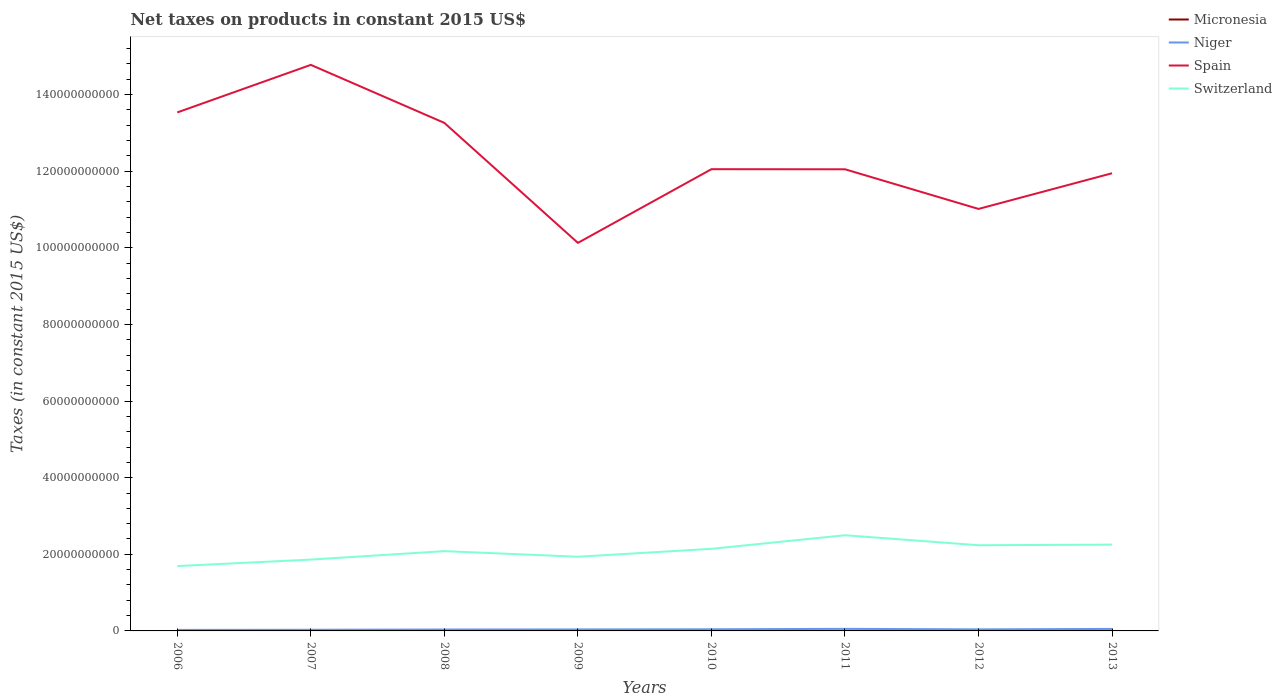How many different coloured lines are there?
Offer a very short reply. 4. Does the line corresponding to Micronesia intersect with the line corresponding to Switzerland?
Give a very brief answer. No. Is the number of lines equal to the number of legend labels?
Your answer should be very brief. Yes. Across all years, what is the maximum net taxes on products in Niger?
Offer a very short reply. 2.64e+08. What is the total net taxes on products in Niger in the graph?
Keep it short and to the point. -9.48e+07. What is the difference between the highest and the second highest net taxes on products in Switzerland?
Your answer should be very brief. 8.05e+09. What is the difference between the highest and the lowest net taxes on products in Niger?
Provide a short and direct response. 4. How many lines are there?
Ensure brevity in your answer.  4. How many years are there in the graph?
Your answer should be compact. 8. Does the graph contain grids?
Keep it short and to the point. No. Where does the legend appear in the graph?
Your answer should be compact. Top right. How many legend labels are there?
Keep it short and to the point. 4. What is the title of the graph?
Your answer should be very brief. Net taxes on products in constant 2015 US$. What is the label or title of the X-axis?
Your answer should be compact. Years. What is the label or title of the Y-axis?
Ensure brevity in your answer.  Taxes (in constant 2015 US$). What is the Taxes (in constant 2015 US$) of Micronesia in 2006?
Your answer should be very brief. 2.11e+07. What is the Taxes (in constant 2015 US$) of Niger in 2006?
Provide a short and direct response. 2.64e+08. What is the Taxes (in constant 2015 US$) in Spain in 2006?
Keep it short and to the point. 1.35e+11. What is the Taxes (in constant 2015 US$) of Switzerland in 2006?
Offer a terse response. 1.69e+1. What is the Taxes (in constant 2015 US$) in Micronesia in 2007?
Provide a succinct answer. 2.04e+07. What is the Taxes (in constant 2015 US$) in Niger in 2007?
Offer a very short reply. 3.02e+08. What is the Taxes (in constant 2015 US$) in Spain in 2007?
Your answer should be very brief. 1.48e+11. What is the Taxes (in constant 2015 US$) in Switzerland in 2007?
Ensure brevity in your answer.  1.86e+1. What is the Taxes (in constant 2015 US$) of Micronesia in 2008?
Ensure brevity in your answer.  1.88e+07. What is the Taxes (in constant 2015 US$) of Niger in 2008?
Provide a succinct answer. 3.72e+08. What is the Taxes (in constant 2015 US$) of Spain in 2008?
Offer a very short reply. 1.33e+11. What is the Taxes (in constant 2015 US$) of Switzerland in 2008?
Give a very brief answer. 2.08e+1. What is the Taxes (in constant 2015 US$) of Micronesia in 2009?
Give a very brief answer. 2.20e+07. What is the Taxes (in constant 2015 US$) in Niger in 2009?
Your response must be concise. 3.93e+08. What is the Taxes (in constant 2015 US$) of Spain in 2009?
Your response must be concise. 1.01e+11. What is the Taxes (in constant 2015 US$) in Switzerland in 2009?
Your answer should be very brief. 1.94e+1. What is the Taxes (in constant 2015 US$) in Micronesia in 2010?
Offer a very short reply. 2.54e+07. What is the Taxes (in constant 2015 US$) in Niger in 2010?
Keep it short and to the point. 4.28e+08. What is the Taxes (in constant 2015 US$) of Spain in 2010?
Provide a succinct answer. 1.21e+11. What is the Taxes (in constant 2015 US$) in Switzerland in 2010?
Ensure brevity in your answer.  2.14e+1. What is the Taxes (in constant 2015 US$) of Micronesia in 2011?
Your response must be concise. 2.60e+07. What is the Taxes (in constant 2015 US$) of Niger in 2011?
Your answer should be very brief. 5.44e+08. What is the Taxes (in constant 2015 US$) in Spain in 2011?
Offer a very short reply. 1.21e+11. What is the Taxes (in constant 2015 US$) in Switzerland in 2011?
Keep it short and to the point. 2.50e+1. What is the Taxes (in constant 2015 US$) of Micronesia in 2012?
Keep it short and to the point. 2.63e+07. What is the Taxes (in constant 2015 US$) in Niger in 2012?
Give a very brief answer. 4.09e+08. What is the Taxes (in constant 2015 US$) of Spain in 2012?
Give a very brief answer. 1.10e+11. What is the Taxes (in constant 2015 US$) of Switzerland in 2012?
Your response must be concise. 2.24e+1. What is the Taxes (in constant 2015 US$) in Micronesia in 2013?
Give a very brief answer. 2.59e+07. What is the Taxes (in constant 2015 US$) of Niger in 2013?
Your response must be concise. 5.23e+08. What is the Taxes (in constant 2015 US$) of Spain in 2013?
Make the answer very short. 1.19e+11. What is the Taxes (in constant 2015 US$) of Switzerland in 2013?
Give a very brief answer. 2.25e+1. Across all years, what is the maximum Taxes (in constant 2015 US$) of Micronesia?
Ensure brevity in your answer.  2.63e+07. Across all years, what is the maximum Taxes (in constant 2015 US$) in Niger?
Provide a short and direct response. 5.44e+08. Across all years, what is the maximum Taxes (in constant 2015 US$) in Spain?
Provide a succinct answer. 1.48e+11. Across all years, what is the maximum Taxes (in constant 2015 US$) in Switzerland?
Your answer should be compact. 2.50e+1. Across all years, what is the minimum Taxes (in constant 2015 US$) in Micronesia?
Offer a terse response. 1.88e+07. Across all years, what is the minimum Taxes (in constant 2015 US$) in Niger?
Offer a terse response. 2.64e+08. Across all years, what is the minimum Taxes (in constant 2015 US$) of Spain?
Your answer should be compact. 1.01e+11. Across all years, what is the minimum Taxes (in constant 2015 US$) in Switzerland?
Offer a terse response. 1.69e+1. What is the total Taxes (in constant 2015 US$) of Micronesia in the graph?
Make the answer very short. 1.86e+08. What is the total Taxes (in constant 2015 US$) in Niger in the graph?
Make the answer very short. 3.24e+09. What is the total Taxes (in constant 2015 US$) in Spain in the graph?
Offer a terse response. 9.88e+11. What is the total Taxes (in constant 2015 US$) of Switzerland in the graph?
Offer a terse response. 1.67e+11. What is the difference between the Taxes (in constant 2015 US$) in Micronesia in 2006 and that in 2007?
Ensure brevity in your answer.  6.88e+05. What is the difference between the Taxes (in constant 2015 US$) in Niger in 2006 and that in 2007?
Provide a short and direct response. -3.77e+07. What is the difference between the Taxes (in constant 2015 US$) in Spain in 2006 and that in 2007?
Provide a succinct answer. -1.24e+1. What is the difference between the Taxes (in constant 2015 US$) of Switzerland in 2006 and that in 2007?
Your response must be concise. -1.69e+09. What is the difference between the Taxes (in constant 2015 US$) in Micronesia in 2006 and that in 2008?
Offer a terse response. 2.27e+06. What is the difference between the Taxes (in constant 2015 US$) of Niger in 2006 and that in 2008?
Ensure brevity in your answer.  -1.07e+08. What is the difference between the Taxes (in constant 2015 US$) of Spain in 2006 and that in 2008?
Your response must be concise. 2.73e+09. What is the difference between the Taxes (in constant 2015 US$) in Switzerland in 2006 and that in 2008?
Offer a very short reply. -3.90e+09. What is the difference between the Taxes (in constant 2015 US$) of Micronesia in 2006 and that in 2009?
Give a very brief answer. -9.20e+05. What is the difference between the Taxes (in constant 2015 US$) in Niger in 2006 and that in 2009?
Provide a short and direct response. -1.29e+08. What is the difference between the Taxes (in constant 2015 US$) of Spain in 2006 and that in 2009?
Give a very brief answer. 3.40e+1. What is the difference between the Taxes (in constant 2015 US$) in Switzerland in 2006 and that in 2009?
Keep it short and to the point. -2.43e+09. What is the difference between the Taxes (in constant 2015 US$) in Micronesia in 2006 and that in 2010?
Offer a terse response. -4.33e+06. What is the difference between the Taxes (in constant 2015 US$) in Niger in 2006 and that in 2010?
Your answer should be compact. -1.64e+08. What is the difference between the Taxes (in constant 2015 US$) in Spain in 2006 and that in 2010?
Make the answer very short. 1.48e+1. What is the difference between the Taxes (in constant 2015 US$) in Switzerland in 2006 and that in 2010?
Your answer should be compact. -4.50e+09. What is the difference between the Taxes (in constant 2015 US$) in Micronesia in 2006 and that in 2011?
Give a very brief answer. -4.92e+06. What is the difference between the Taxes (in constant 2015 US$) in Niger in 2006 and that in 2011?
Provide a short and direct response. -2.79e+08. What is the difference between the Taxes (in constant 2015 US$) in Spain in 2006 and that in 2011?
Make the answer very short. 1.48e+1. What is the difference between the Taxes (in constant 2015 US$) in Switzerland in 2006 and that in 2011?
Offer a very short reply. -8.05e+09. What is the difference between the Taxes (in constant 2015 US$) in Micronesia in 2006 and that in 2012?
Ensure brevity in your answer.  -5.20e+06. What is the difference between the Taxes (in constant 2015 US$) in Niger in 2006 and that in 2012?
Your answer should be compact. -1.45e+08. What is the difference between the Taxes (in constant 2015 US$) in Spain in 2006 and that in 2012?
Provide a succinct answer. 2.52e+1. What is the difference between the Taxes (in constant 2015 US$) in Switzerland in 2006 and that in 2012?
Make the answer very short. -5.44e+09. What is the difference between the Taxes (in constant 2015 US$) in Micronesia in 2006 and that in 2013?
Your answer should be very brief. -4.80e+06. What is the difference between the Taxes (in constant 2015 US$) of Niger in 2006 and that in 2013?
Make the answer very short. -2.59e+08. What is the difference between the Taxes (in constant 2015 US$) in Spain in 2006 and that in 2013?
Offer a terse response. 1.59e+1. What is the difference between the Taxes (in constant 2015 US$) of Switzerland in 2006 and that in 2013?
Your answer should be compact. -5.60e+09. What is the difference between the Taxes (in constant 2015 US$) in Micronesia in 2007 and that in 2008?
Provide a short and direct response. 1.59e+06. What is the difference between the Taxes (in constant 2015 US$) of Niger in 2007 and that in 2008?
Keep it short and to the point. -6.97e+07. What is the difference between the Taxes (in constant 2015 US$) of Spain in 2007 and that in 2008?
Your answer should be very brief. 1.51e+1. What is the difference between the Taxes (in constant 2015 US$) in Switzerland in 2007 and that in 2008?
Offer a very short reply. -2.21e+09. What is the difference between the Taxes (in constant 2015 US$) in Micronesia in 2007 and that in 2009?
Your answer should be compact. -1.61e+06. What is the difference between the Taxes (in constant 2015 US$) of Niger in 2007 and that in 2009?
Your response must be concise. -9.09e+07. What is the difference between the Taxes (in constant 2015 US$) of Spain in 2007 and that in 2009?
Keep it short and to the point. 4.65e+1. What is the difference between the Taxes (in constant 2015 US$) of Switzerland in 2007 and that in 2009?
Your response must be concise. -7.42e+08. What is the difference between the Taxes (in constant 2015 US$) in Micronesia in 2007 and that in 2010?
Your answer should be very brief. -5.02e+06. What is the difference between the Taxes (in constant 2015 US$) of Niger in 2007 and that in 2010?
Give a very brief answer. -1.26e+08. What is the difference between the Taxes (in constant 2015 US$) in Spain in 2007 and that in 2010?
Your response must be concise. 2.72e+1. What is the difference between the Taxes (in constant 2015 US$) of Switzerland in 2007 and that in 2010?
Provide a succinct answer. -2.81e+09. What is the difference between the Taxes (in constant 2015 US$) in Micronesia in 2007 and that in 2011?
Provide a short and direct response. -5.61e+06. What is the difference between the Taxes (in constant 2015 US$) of Niger in 2007 and that in 2011?
Ensure brevity in your answer.  -2.42e+08. What is the difference between the Taxes (in constant 2015 US$) of Spain in 2007 and that in 2011?
Your answer should be compact. 2.73e+1. What is the difference between the Taxes (in constant 2015 US$) in Switzerland in 2007 and that in 2011?
Provide a short and direct response. -6.36e+09. What is the difference between the Taxes (in constant 2015 US$) in Micronesia in 2007 and that in 2012?
Your answer should be compact. -5.89e+06. What is the difference between the Taxes (in constant 2015 US$) of Niger in 2007 and that in 2012?
Give a very brief answer. -1.07e+08. What is the difference between the Taxes (in constant 2015 US$) of Spain in 2007 and that in 2012?
Offer a terse response. 3.76e+1. What is the difference between the Taxes (in constant 2015 US$) of Switzerland in 2007 and that in 2012?
Provide a succinct answer. -3.75e+09. What is the difference between the Taxes (in constant 2015 US$) of Micronesia in 2007 and that in 2013?
Your response must be concise. -5.49e+06. What is the difference between the Taxes (in constant 2015 US$) of Niger in 2007 and that in 2013?
Make the answer very short. -2.21e+08. What is the difference between the Taxes (in constant 2015 US$) of Spain in 2007 and that in 2013?
Your answer should be compact. 2.83e+1. What is the difference between the Taxes (in constant 2015 US$) of Switzerland in 2007 and that in 2013?
Make the answer very short. -3.91e+09. What is the difference between the Taxes (in constant 2015 US$) in Micronesia in 2008 and that in 2009?
Offer a very short reply. -3.19e+06. What is the difference between the Taxes (in constant 2015 US$) in Niger in 2008 and that in 2009?
Your answer should be compact. -2.12e+07. What is the difference between the Taxes (in constant 2015 US$) in Spain in 2008 and that in 2009?
Provide a succinct answer. 3.13e+1. What is the difference between the Taxes (in constant 2015 US$) in Switzerland in 2008 and that in 2009?
Give a very brief answer. 1.47e+09. What is the difference between the Taxes (in constant 2015 US$) of Micronesia in 2008 and that in 2010?
Make the answer very short. -6.60e+06. What is the difference between the Taxes (in constant 2015 US$) of Niger in 2008 and that in 2010?
Ensure brevity in your answer.  -5.65e+07. What is the difference between the Taxes (in constant 2015 US$) in Spain in 2008 and that in 2010?
Your answer should be very brief. 1.21e+1. What is the difference between the Taxes (in constant 2015 US$) of Switzerland in 2008 and that in 2010?
Give a very brief answer. -6.00e+08. What is the difference between the Taxes (in constant 2015 US$) in Micronesia in 2008 and that in 2011?
Keep it short and to the point. -7.19e+06. What is the difference between the Taxes (in constant 2015 US$) of Niger in 2008 and that in 2011?
Keep it short and to the point. -1.72e+08. What is the difference between the Taxes (in constant 2015 US$) of Spain in 2008 and that in 2011?
Offer a very short reply. 1.21e+1. What is the difference between the Taxes (in constant 2015 US$) of Switzerland in 2008 and that in 2011?
Your answer should be compact. -4.15e+09. What is the difference between the Taxes (in constant 2015 US$) of Micronesia in 2008 and that in 2012?
Provide a short and direct response. -7.48e+06. What is the difference between the Taxes (in constant 2015 US$) of Niger in 2008 and that in 2012?
Your answer should be very brief. -3.75e+07. What is the difference between the Taxes (in constant 2015 US$) of Spain in 2008 and that in 2012?
Your answer should be compact. 2.25e+1. What is the difference between the Taxes (in constant 2015 US$) in Switzerland in 2008 and that in 2012?
Offer a terse response. -1.54e+09. What is the difference between the Taxes (in constant 2015 US$) in Micronesia in 2008 and that in 2013?
Offer a terse response. -7.08e+06. What is the difference between the Taxes (in constant 2015 US$) of Niger in 2008 and that in 2013?
Give a very brief answer. -1.51e+08. What is the difference between the Taxes (in constant 2015 US$) of Spain in 2008 and that in 2013?
Give a very brief answer. 1.31e+1. What is the difference between the Taxes (in constant 2015 US$) of Switzerland in 2008 and that in 2013?
Your answer should be very brief. -1.70e+09. What is the difference between the Taxes (in constant 2015 US$) in Micronesia in 2009 and that in 2010?
Make the answer very short. -3.41e+06. What is the difference between the Taxes (in constant 2015 US$) in Niger in 2009 and that in 2010?
Make the answer very short. -3.53e+07. What is the difference between the Taxes (in constant 2015 US$) of Spain in 2009 and that in 2010?
Provide a succinct answer. -1.92e+1. What is the difference between the Taxes (in constant 2015 US$) of Switzerland in 2009 and that in 2010?
Make the answer very short. -2.07e+09. What is the difference between the Taxes (in constant 2015 US$) in Micronesia in 2009 and that in 2011?
Offer a very short reply. -4.00e+06. What is the difference between the Taxes (in constant 2015 US$) in Niger in 2009 and that in 2011?
Provide a succinct answer. -1.51e+08. What is the difference between the Taxes (in constant 2015 US$) in Spain in 2009 and that in 2011?
Offer a very short reply. -1.92e+1. What is the difference between the Taxes (in constant 2015 US$) in Switzerland in 2009 and that in 2011?
Keep it short and to the point. -5.62e+09. What is the difference between the Taxes (in constant 2015 US$) of Micronesia in 2009 and that in 2012?
Offer a terse response. -4.28e+06. What is the difference between the Taxes (in constant 2015 US$) in Niger in 2009 and that in 2012?
Offer a terse response. -1.63e+07. What is the difference between the Taxes (in constant 2015 US$) of Spain in 2009 and that in 2012?
Ensure brevity in your answer.  -8.86e+09. What is the difference between the Taxes (in constant 2015 US$) in Switzerland in 2009 and that in 2012?
Ensure brevity in your answer.  -3.01e+09. What is the difference between the Taxes (in constant 2015 US$) in Micronesia in 2009 and that in 2013?
Your answer should be compact. -3.88e+06. What is the difference between the Taxes (in constant 2015 US$) in Niger in 2009 and that in 2013?
Ensure brevity in your answer.  -1.30e+08. What is the difference between the Taxes (in constant 2015 US$) of Spain in 2009 and that in 2013?
Your answer should be compact. -1.82e+1. What is the difference between the Taxes (in constant 2015 US$) of Switzerland in 2009 and that in 2013?
Ensure brevity in your answer.  -3.17e+09. What is the difference between the Taxes (in constant 2015 US$) of Micronesia in 2010 and that in 2011?
Keep it short and to the point. -5.89e+05. What is the difference between the Taxes (in constant 2015 US$) in Niger in 2010 and that in 2011?
Your answer should be very brief. -1.16e+08. What is the difference between the Taxes (in constant 2015 US$) in Spain in 2010 and that in 2011?
Provide a short and direct response. 2.38e+07. What is the difference between the Taxes (in constant 2015 US$) of Switzerland in 2010 and that in 2011?
Provide a short and direct response. -3.55e+09. What is the difference between the Taxes (in constant 2015 US$) in Micronesia in 2010 and that in 2012?
Your response must be concise. -8.73e+05. What is the difference between the Taxes (in constant 2015 US$) in Niger in 2010 and that in 2012?
Your answer should be very brief. 1.90e+07. What is the difference between the Taxes (in constant 2015 US$) of Spain in 2010 and that in 2012?
Your answer should be compact. 1.04e+1. What is the difference between the Taxes (in constant 2015 US$) of Switzerland in 2010 and that in 2012?
Offer a very short reply. -9.41e+08. What is the difference between the Taxes (in constant 2015 US$) in Micronesia in 2010 and that in 2013?
Your answer should be very brief. -4.73e+05. What is the difference between the Taxes (in constant 2015 US$) in Niger in 2010 and that in 2013?
Offer a very short reply. -9.48e+07. What is the difference between the Taxes (in constant 2015 US$) in Spain in 2010 and that in 2013?
Provide a short and direct response. 1.06e+09. What is the difference between the Taxes (in constant 2015 US$) of Switzerland in 2010 and that in 2013?
Provide a short and direct response. -1.10e+09. What is the difference between the Taxes (in constant 2015 US$) in Micronesia in 2011 and that in 2012?
Offer a terse response. -2.83e+05. What is the difference between the Taxes (in constant 2015 US$) in Niger in 2011 and that in 2012?
Your answer should be very brief. 1.35e+08. What is the difference between the Taxes (in constant 2015 US$) of Spain in 2011 and that in 2012?
Your response must be concise. 1.04e+1. What is the difference between the Taxes (in constant 2015 US$) in Switzerland in 2011 and that in 2012?
Give a very brief answer. 2.61e+09. What is the difference between the Taxes (in constant 2015 US$) of Micronesia in 2011 and that in 2013?
Provide a short and direct response. 1.17e+05. What is the difference between the Taxes (in constant 2015 US$) of Niger in 2011 and that in 2013?
Your answer should be compact. 2.08e+07. What is the difference between the Taxes (in constant 2015 US$) in Spain in 2011 and that in 2013?
Provide a short and direct response. 1.04e+09. What is the difference between the Taxes (in constant 2015 US$) of Switzerland in 2011 and that in 2013?
Offer a very short reply. 2.45e+09. What is the difference between the Taxes (in constant 2015 US$) of Micronesia in 2012 and that in 2013?
Offer a very short reply. 4.00e+05. What is the difference between the Taxes (in constant 2015 US$) in Niger in 2012 and that in 2013?
Provide a succinct answer. -1.14e+08. What is the difference between the Taxes (in constant 2015 US$) in Spain in 2012 and that in 2013?
Your response must be concise. -9.31e+09. What is the difference between the Taxes (in constant 2015 US$) in Switzerland in 2012 and that in 2013?
Provide a succinct answer. -1.56e+08. What is the difference between the Taxes (in constant 2015 US$) of Micronesia in 2006 and the Taxes (in constant 2015 US$) of Niger in 2007?
Provide a short and direct response. -2.81e+08. What is the difference between the Taxes (in constant 2015 US$) of Micronesia in 2006 and the Taxes (in constant 2015 US$) of Spain in 2007?
Your response must be concise. -1.48e+11. What is the difference between the Taxes (in constant 2015 US$) in Micronesia in 2006 and the Taxes (in constant 2015 US$) in Switzerland in 2007?
Your answer should be compact. -1.86e+1. What is the difference between the Taxes (in constant 2015 US$) in Niger in 2006 and the Taxes (in constant 2015 US$) in Spain in 2007?
Ensure brevity in your answer.  -1.47e+11. What is the difference between the Taxes (in constant 2015 US$) of Niger in 2006 and the Taxes (in constant 2015 US$) of Switzerland in 2007?
Ensure brevity in your answer.  -1.84e+1. What is the difference between the Taxes (in constant 2015 US$) in Spain in 2006 and the Taxes (in constant 2015 US$) in Switzerland in 2007?
Your answer should be compact. 1.17e+11. What is the difference between the Taxes (in constant 2015 US$) in Micronesia in 2006 and the Taxes (in constant 2015 US$) in Niger in 2008?
Make the answer very short. -3.51e+08. What is the difference between the Taxes (in constant 2015 US$) of Micronesia in 2006 and the Taxes (in constant 2015 US$) of Spain in 2008?
Your answer should be compact. -1.33e+11. What is the difference between the Taxes (in constant 2015 US$) of Micronesia in 2006 and the Taxes (in constant 2015 US$) of Switzerland in 2008?
Your answer should be very brief. -2.08e+1. What is the difference between the Taxes (in constant 2015 US$) in Niger in 2006 and the Taxes (in constant 2015 US$) in Spain in 2008?
Your response must be concise. -1.32e+11. What is the difference between the Taxes (in constant 2015 US$) in Niger in 2006 and the Taxes (in constant 2015 US$) in Switzerland in 2008?
Offer a terse response. -2.06e+1. What is the difference between the Taxes (in constant 2015 US$) of Spain in 2006 and the Taxes (in constant 2015 US$) of Switzerland in 2008?
Give a very brief answer. 1.15e+11. What is the difference between the Taxes (in constant 2015 US$) of Micronesia in 2006 and the Taxes (in constant 2015 US$) of Niger in 2009?
Give a very brief answer. -3.72e+08. What is the difference between the Taxes (in constant 2015 US$) of Micronesia in 2006 and the Taxes (in constant 2015 US$) of Spain in 2009?
Provide a short and direct response. -1.01e+11. What is the difference between the Taxes (in constant 2015 US$) of Micronesia in 2006 and the Taxes (in constant 2015 US$) of Switzerland in 2009?
Your answer should be compact. -1.93e+1. What is the difference between the Taxes (in constant 2015 US$) of Niger in 2006 and the Taxes (in constant 2015 US$) of Spain in 2009?
Offer a very short reply. -1.01e+11. What is the difference between the Taxes (in constant 2015 US$) in Niger in 2006 and the Taxes (in constant 2015 US$) in Switzerland in 2009?
Provide a succinct answer. -1.91e+1. What is the difference between the Taxes (in constant 2015 US$) of Spain in 2006 and the Taxes (in constant 2015 US$) of Switzerland in 2009?
Ensure brevity in your answer.  1.16e+11. What is the difference between the Taxes (in constant 2015 US$) in Micronesia in 2006 and the Taxes (in constant 2015 US$) in Niger in 2010?
Offer a terse response. -4.07e+08. What is the difference between the Taxes (in constant 2015 US$) of Micronesia in 2006 and the Taxes (in constant 2015 US$) of Spain in 2010?
Keep it short and to the point. -1.21e+11. What is the difference between the Taxes (in constant 2015 US$) in Micronesia in 2006 and the Taxes (in constant 2015 US$) in Switzerland in 2010?
Keep it short and to the point. -2.14e+1. What is the difference between the Taxes (in constant 2015 US$) in Niger in 2006 and the Taxes (in constant 2015 US$) in Spain in 2010?
Make the answer very short. -1.20e+11. What is the difference between the Taxes (in constant 2015 US$) of Niger in 2006 and the Taxes (in constant 2015 US$) of Switzerland in 2010?
Your response must be concise. -2.12e+1. What is the difference between the Taxes (in constant 2015 US$) in Spain in 2006 and the Taxes (in constant 2015 US$) in Switzerland in 2010?
Make the answer very short. 1.14e+11. What is the difference between the Taxes (in constant 2015 US$) in Micronesia in 2006 and the Taxes (in constant 2015 US$) in Niger in 2011?
Provide a short and direct response. -5.23e+08. What is the difference between the Taxes (in constant 2015 US$) of Micronesia in 2006 and the Taxes (in constant 2015 US$) of Spain in 2011?
Your answer should be very brief. -1.20e+11. What is the difference between the Taxes (in constant 2015 US$) in Micronesia in 2006 and the Taxes (in constant 2015 US$) in Switzerland in 2011?
Keep it short and to the point. -2.50e+1. What is the difference between the Taxes (in constant 2015 US$) of Niger in 2006 and the Taxes (in constant 2015 US$) of Spain in 2011?
Provide a succinct answer. -1.20e+11. What is the difference between the Taxes (in constant 2015 US$) in Niger in 2006 and the Taxes (in constant 2015 US$) in Switzerland in 2011?
Offer a very short reply. -2.47e+1. What is the difference between the Taxes (in constant 2015 US$) of Spain in 2006 and the Taxes (in constant 2015 US$) of Switzerland in 2011?
Make the answer very short. 1.10e+11. What is the difference between the Taxes (in constant 2015 US$) of Micronesia in 2006 and the Taxes (in constant 2015 US$) of Niger in 2012?
Offer a terse response. -3.88e+08. What is the difference between the Taxes (in constant 2015 US$) of Micronesia in 2006 and the Taxes (in constant 2015 US$) of Spain in 2012?
Offer a terse response. -1.10e+11. What is the difference between the Taxes (in constant 2015 US$) in Micronesia in 2006 and the Taxes (in constant 2015 US$) in Switzerland in 2012?
Ensure brevity in your answer.  -2.23e+1. What is the difference between the Taxes (in constant 2015 US$) in Niger in 2006 and the Taxes (in constant 2015 US$) in Spain in 2012?
Ensure brevity in your answer.  -1.10e+11. What is the difference between the Taxes (in constant 2015 US$) of Niger in 2006 and the Taxes (in constant 2015 US$) of Switzerland in 2012?
Offer a very short reply. -2.21e+1. What is the difference between the Taxes (in constant 2015 US$) of Spain in 2006 and the Taxes (in constant 2015 US$) of Switzerland in 2012?
Provide a succinct answer. 1.13e+11. What is the difference between the Taxes (in constant 2015 US$) of Micronesia in 2006 and the Taxes (in constant 2015 US$) of Niger in 2013?
Keep it short and to the point. -5.02e+08. What is the difference between the Taxes (in constant 2015 US$) in Micronesia in 2006 and the Taxes (in constant 2015 US$) in Spain in 2013?
Your answer should be very brief. -1.19e+11. What is the difference between the Taxes (in constant 2015 US$) in Micronesia in 2006 and the Taxes (in constant 2015 US$) in Switzerland in 2013?
Provide a succinct answer. -2.25e+1. What is the difference between the Taxes (in constant 2015 US$) of Niger in 2006 and the Taxes (in constant 2015 US$) of Spain in 2013?
Ensure brevity in your answer.  -1.19e+11. What is the difference between the Taxes (in constant 2015 US$) of Niger in 2006 and the Taxes (in constant 2015 US$) of Switzerland in 2013?
Your response must be concise. -2.23e+1. What is the difference between the Taxes (in constant 2015 US$) of Spain in 2006 and the Taxes (in constant 2015 US$) of Switzerland in 2013?
Offer a very short reply. 1.13e+11. What is the difference between the Taxes (in constant 2015 US$) in Micronesia in 2007 and the Taxes (in constant 2015 US$) in Niger in 2008?
Make the answer very short. -3.51e+08. What is the difference between the Taxes (in constant 2015 US$) of Micronesia in 2007 and the Taxes (in constant 2015 US$) of Spain in 2008?
Make the answer very short. -1.33e+11. What is the difference between the Taxes (in constant 2015 US$) of Micronesia in 2007 and the Taxes (in constant 2015 US$) of Switzerland in 2008?
Provide a succinct answer. -2.08e+1. What is the difference between the Taxes (in constant 2015 US$) of Niger in 2007 and the Taxes (in constant 2015 US$) of Spain in 2008?
Make the answer very short. -1.32e+11. What is the difference between the Taxes (in constant 2015 US$) of Niger in 2007 and the Taxes (in constant 2015 US$) of Switzerland in 2008?
Give a very brief answer. -2.05e+1. What is the difference between the Taxes (in constant 2015 US$) in Spain in 2007 and the Taxes (in constant 2015 US$) in Switzerland in 2008?
Make the answer very short. 1.27e+11. What is the difference between the Taxes (in constant 2015 US$) of Micronesia in 2007 and the Taxes (in constant 2015 US$) of Niger in 2009?
Your response must be concise. -3.73e+08. What is the difference between the Taxes (in constant 2015 US$) of Micronesia in 2007 and the Taxes (in constant 2015 US$) of Spain in 2009?
Offer a terse response. -1.01e+11. What is the difference between the Taxes (in constant 2015 US$) of Micronesia in 2007 and the Taxes (in constant 2015 US$) of Switzerland in 2009?
Provide a short and direct response. -1.93e+1. What is the difference between the Taxes (in constant 2015 US$) of Niger in 2007 and the Taxes (in constant 2015 US$) of Spain in 2009?
Offer a very short reply. -1.01e+11. What is the difference between the Taxes (in constant 2015 US$) in Niger in 2007 and the Taxes (in constant 2015 US$) in Switzerland in 2009?
Your response must be concise. -1.91e+1. What is the difference between the Taxes (in constant 2015 US$) of Spain in 2007 and the Taxes (in constant 2015 US$) of Switzerland in 2009?
Keep it short and to the point. 1.28e+11. What is the difference between the Taxes (in constant 2015 US$) in Micronesia in 2007 and the Taxes (in constant 2015 US$) in Niger in 2010?
Your answer should be very brief. -4.08e+08. What is the difference between the Taxes (in constant 2015 US$) of Micronesia in 2007 and the Taxes (in constant 2015 US$) of Spain in 2010?
Give a very brief answer. -1.21e+11. What is the difference between the Taxes (in constant 2015 US$) of Micronesia in 2007 and the Taxes (in constant 2015 US$) of Switzerland in 2010?
Ensure brevity in your answer.  -2.14e+1. What is the difference between the Taxes (in constant 2015 US$) of Niger in 2007 and the Taxes (in constant 2015 US$) of Spain in 2010?
Keep it short and to the point. -1.20e+11. What is the difference between the Taxes (in constant 2015 US$) in Niger in 2007 and the Taxes (in constant 2015 US$) in Switzerland in 2010?
Your answer should be compact. -2.11e+1. What is the difference between the Taxes (in constant 2015 US$) of Spain in 2007 and the Taxes (in constant 2015 US$) of Switzerland in 2010?
Your response must be concise. 1.26e+11. What is the difference between the Taxes (in constant 2015 US$) in Micronesia in 2007 and the Taxes (in constant 2015 US$) in Niger in 2011?
Ensure brevity in your answer.  -5.23e+08. What is the difference between the Taxes (in constant 2015 US$) in Micronesia in 2007 and the Taxes (in constant 2015 US$) in Spain in 2011?
Ensure brevity in your answer.  -1.20e+11. What is the difference between the Taxes (in constant 2015 US$) in Micronesia in 2007 and the Taxes (in constant 2015 US$) in Switzerland in 2011?
Offer a very short reply. -2.50e+1. What is the difference between the Taxes (in constant 2015 US$) in Niger in 2007 and the Taxes (in constant 2015 US$) in Spain in 2011?
Make the answer very short. -1.20e+11. What is the difference between the Taxes (in constant 2015 US$) in Niger in 2007 and the Taxes (in constant 2015 US$) in Switzerland in 2011?
Provide a succinct answer. -2.47e+1. What is the difference between the Taxes (in constant 2015 US$) of Spain in 2007 and the Taxes (in constant 2015 US$) of Switzerland in 2011?
Ensure brevity in your answer.  1.23e+11. What is the difference between the Taxes (in constant 2015 US$) in Micronesia in 2007 and the Taxes (in constant 2015 US$) in Niger in 2012?
Your response must be concise. -3.89e+08. What is the difference between the Taxes (in constant 2015 US$) of Micronesia in 2007 and the Taxes (in constant 2015 US$) of Spain in 2012?
Ensure brevity in your answer.  -1.10e+11. What is the difference between the Taxes (in constant 2015 US$) of Micronesia in 2007 and the Taxes (in constant 2015 US$) of Switzerland in 2012?
Your response must be concise. -2.24e+1. What is the difference between the Taxes (in constant 2015 US$) of Niger in 2007 and the Taxes (in constant 2015 US$) of Spain in 2012?
Provide a succinct answer. -1.10e+11. What is the difference between the Taxes (in constant 2015 US$) in Niger in 2007 and the Taxes (in constant 2015 US$) in Switzerland in 2012?
Offer a terse response. -2.21e+1. What is the difference between the Taxes (in constant 2015 US$) of Spain in 2007 and the Taxes (in constant 2015 US$) of Switzerland in 2012?
Offer a very short reply. 1.25e+11. What is the difference between the Taxes (in constant 2015 US$) in Micronesia in 2007 and the Taxes (in constant 2015 US$) in Niger in 2013?
Offer a very short reply. -5.03e+08. What is the difference between the Taxes (in constant 2015 US$) in Micronesia in 2007 and the Taxes (in constant 2015 US$) in Spain in 2013?
Keep it short and to the point. -1.19e+11. What is the difference between the Taxes (in constant 2015 US$) of Micronesia in 2007 and the Taxes (in constant 2015 US$) of Switzerland in 2013?
Your answer should be compact. -2.25e+1. What is the difference between the Taxes (in constant 2015 US$) in Niger in 2007 and the Taxes (in constant 2015 US$) in Spain in 2013?
Offer a terse response. -1.19e+11. What is the difference between the Taxes (in constant 2015 US$) in Niger in 2007 and the Taxes (in constant 2015 US$) in Switzerland in 2013?
Provide a short and direct response. -2.22e+1. What is the difference between the Taxes (in constant 2015 US$) of Spain in 2007 and the Taxes (in constant 2015 US$) of Switzerland in 2013?
Your answer should be very brief. 1.25e+11. What is the difference between the Taxes (in constant 2015 US$) of Micronesia in 2008 and the Taxes (in constant 2015 US$) of Niger in 2009?
Offer a very short reply. -3.74e+08. What is the difference between the Taxes (in constant 2015 US$) in Micronesia in 2008 and the Taxes (in constant 2015 US$) in Spain in 2009?
Ensure brevity in your answer.  -1.01e+11. What is the difference between the Taxes (in constant 2015 US$) in Micronesia in 2008 and the Taxes (in constant 2015 US$) in Switzerland in 2009?
Offer a very short reply. -1.93e+1. What is the difference between the Taxes (in constant 2015 US$) in Niger in 2008 and the Taxes (in constant 2015 US$) in Spain in 2009?
Keep it short and to the point. -1.01e+11. What is the difference between the Taxes (in constant 2015 US$) in Niger in 2008 and the Taxes (in constant 2015 US$) in Switzerland in 2009?
Offer a very short reply. -1.90e+1. What is the difference between the Taxes (in constant 2015 US$) of Spain in 2008 and the Taxes (in constant 2015 US$) of Switzerland in 2009?
Offer a terse response. 1.13e+11. What is the difference between the Taxes (in constant 2015 US$) of Micronesia in 2008 and the Taxes (in constant 2015 US$) of Niger in 2010?
Provide a short and direct response. -4.09e+08. What is the difference between the Taxes (in constant 2015 US$) of Micronesia in 2008 and the Taxes (in constant 2015 US$) of Spain in 2010?
Ensure brevity in your answer.  -1.21e+11. What is the difference between the Taxes (in constant 2015 US$) in Micronesia in 2008 and the Taxes (in constant 2015 US$) in Switzerland in 2010?
Ensure brevity in your answer.  -2.14e+1. What is the difference between the Taxes (in constant 2015 US$) of Niger in 2008 and the Taxes (in constant 2015 US$) of Spain in 2010?
Give a very brief answer. -1.20e+11. What is the difference between the Taxes (in constant 2015 US$) of Niger in 2008 and the Taxes (in constant 2015 US$) of Switzerland in 2010?
Ensure brevity in your answer.  -2.11e+1. What is the difference between the Taxes (in constant 2015 US$) in Spain in 2008 and the Taxes (in constant 2015 US$) in Switzerland in 2010?
Offer a terse response. 1.11e+11. What is the difference between the Taxes (in constant 2015 US$) of Micronesia in 2008 and the Taxes (in constant 2015 US$) of Niger in 2011?
Give a very brief answer. -5.25e+08. What is the difference between the Taxes (in constant 2015 US$) of Micronesia in 2008 and the Taxes (in constant 2015 US$) of Spain in 2011?
Make the answer very short. -1.20e+11. What is the difference between the Taxes (in constant 2015 US$) in Micronesia in 2008 and the Taxes (in constant 2015 US$) in Switzerland in 2011?
Provide a succinct answer. -2.50e+1. What is the difference between the Taxes (in constant 2015 US$) in Niger in 2008 and the Taxes (in constant 2015 US$) in Spain in 2011?
Give a very brief answer. -1.20e+11. What is the difference between the Taxes (in constant 2015 US$) in Niger in 2008 and the Taxes (in constant 2015 US$) in Switzerland in 2011?
Provide a short and direct response. -2.46e+1. What is the difference between the Taxes (in constant 2015 US$) of Spain in 2008 and the Taxes (in constant 2015 US$) of Switzerland in 2011?
Offer a very short reply. 1.08e+11. What is the difference between the Taxes (in constant 2015 US$) of Micronesia in 2008 and the Taxes (in constant 2015 US$) of Niger in 2012?
Provide a short and direct response. -3.90e+08. What is the difference between the Taxes (in constant 2015 US$) of Micronesia in 2008 and the Taxes (in constant 2015 US$) of Spain in 2012?
Offer a very short reply. -1.10e+11. What is the difference between the Taxes (in constant 2015 US$) of Micronesia in 2008 and the Taxes (in constant 2015 US$) of Switzerland in 2012?
Provide a succinct answer. -2.24e+1. What is the difference between the Taxes (in constant 2015 US$) in Niger in 2008 and the Taxes (in constant 2015 US$) in Spain in 2012?
Make the answer very short. -1.10e+11. What is the difference between the Taxes (in constant 2015 US$) in Niger in 2008 and the Taxes (in constant 2015 US$) in Switzerland in 2012?
Keep it short and to the point. -2.20e+1. What is the difference between the Taxes (in constant 2015 US$) of Spain in 2008 and the Taxes (in constant 2015 US$) of Switzerland in 2012?
Provide a succinct answer. 1.10e+11. What is the difference between the Taxes (in constant 2015 US$) of Micronesia in 2008 and the Taxes (in constant 2015 US$) of Niger in 2013?
Offer a very short reply. -5.04e+08. What is the difference between the Taxes (in constant 2015 US$) of Micronesia in 2008 and the Taxes (in constant 2015 US$) of Spain in 2013?
Offer a terse response. -1.19e+11. What is the difference between the Taxes (in constant 2015 US$) in Micronesia in 2008 and the Taxes (in constant 2015 US$) in Switzerland in 2013?
Your response must be concise. -2.25e+1. What is the difference between the Taxes (in constant 2015 US$) in Niger in 2008 and the Taxes (in constant 2015 US$) in Spain in 2013?
Keep it short and to the point. -1.19e+11. What is the difference between the Taxes (in constant 2015 US$) in Niger in 2008 and the Taxes (in constant 2015 US$) in Switzerland in 2013?
Ensure brevity in your answer.  -2.22e+1. What is the difference between the Taxes (in constant 2015 US$) in Spain in 2008 and the Taxes (in constant 2015 US$) in Switzerland in 2013?
Make the answer very short. 1.10e+11. What is the difference between the Taxes (in constant 2015 US$) in Micronesia in 2009 and the Taxes (in constant 2015 US$) in Niger in 2010?
Provide a short and direct response. -4.06e+08. What is the difference between the Taxes (in constant 2015 US$) in Micronesia in 2009 and the Taxes (in constant 2015 US$) in Spain in 2010?
Ensure brevity in your answer.  -1.21e+11. What is the difference between the Taxes (in constant 2015 US$) of Micronesia in 2009 and the Taxes (in constant 2015 US$) of Switzerland in 2010?
Keep it short and to the point. -2.14e+1. What is the difference between the Taxes (in constant 2015 US$) in Niger in 2009 and the Taxes (in constant 2015 US$) in Spain in 2010?
Your response must be concise. -1.20e+11. What is the difference between the Taxes (in constant 2015 US$) of Niger in 2009 and the Taxes (in constant 2015 US$) of Switzerland in 2010?
Keep it short and to the point. -2.10e+1. What is the difference between the Taxes (in constant 2015 US$) in Spain in 2009 and the Taxes (in constant 2015 US$) in Switzerland in 2010?
Provide a short and direct response. 7.99e+1. What is the difference between the Taxes (in constant 2015 US$) in Micronesia in 2009 and the Taxes (in constant 2015 US$) in Niger in 2011?
Provide a succinct answer. -5.22e+08. What is the difference between the Taxes (in constant 2015 US$) in Micronesia in 2009 and the Taxes (in constant 2015 US$) in Spain in 2011?
Your answer should be compact. -1.20e+11. What is the difference between the Taxes (in constant 2015 US$) in Micronesia in 2009 and the Taxes (in constant 2015 US$) in Switzerland in 2011?
Your response must be concise. -2.50e+1. What is the difference between the Taxes (in constant 2015 US$) in Niger in 2009 and the Taxes (in constant 2015 US$) in Spain in 2011?
Provide a succinct answer. -1.20e+11. What is the difference between the Taxes (in constant 2015 US$) in Niger in 2009 and the Taxes (in constant 2015 US$) in Switzerland in 2011?
Your answer should be very brief. -2.46e+1. What is the difference between the Taxes (in constant 2015 US$) in Spain in 2009 and the Taxes (in constant 2015 US$) in Switzerland in 2011?
Give a very brief answer. 7.63e+1. What is the difference between the Taxes (in constant 2015 US$) of Micronesia in 2009 and the Taxes (in constant 2015 US$) of Niger in 2012?
Offer a terse response. -3.87e+08. What is the difference between the Taxes (in constant 2015 US$) of Micronesia in 2009 and the Taxes (in constant 2015 US$) of Spain in 2012?
Your response must be concise. -1.10e+11. What is the difference between the Taxes (in constant 2015 US$) in Micronesia in 2009 and the Taxes (in constant 2015 US$) in Switzerland in 2012?
Make the answer very short. -2.23e+1. What is the difference between the Taxes (in constant 2015 US$) of Niger in 2009 and the Taxes (in constant 2015 US$) of Spain in 2012?
Ensure brevity in your answer.  -1.10e+11. What is the difference between the Taxes (in constant 2015 US$) of Niger in 2009 and the Taxes (in constant 2015 US$) of Switzerland in 2012?
Your answer should be very brief. -2.20e+1. What is the difference between the Taxes (in constant 2015 US$) of Spain in 2009 and the Taxes (in constant 2015 US$) of Switzerland in 2012?
Your answer should be compact. 7.89e+1. What is the difference between the Taxes (in constant 2015 US$) in Micronesia in 2009 and the Taxes (in constant 2015 US$) in Niger in 2013?
Offer a very short reply. -5.01e+08. What is the difference between the Taxes (in constant 2015 US$) in Micronesia in 2009 and the Taxes (in constant 2015 US$) in Spain in 2013?
Your answer should be compact. -1.19e+11. What is the difference between the Taxes (in constant 2015 US$) of Micronesia in 2009 and the Taxes (in constant 2015 US$) of Switzerland in 2013?
Make the answer very short. -2.25e+1. What is the difference between the Taxes (in constant 2015 US$) of Niger in 2009 and the Taxes (in constant 2015 US$) of Spain in 2013?
Your answer should be very brief. -1.19e+11. What is the difference between the Taxes (in constant 2015 US$) of Niger in 2009 and the Taxes (in constant 2015 US$) of Switzerland in 2013?
Your answer should be very brief. -2.21e+1. What is the difference between the Taxes (in constant 2015 US$) of Spain in 2009 and the Taxes (in constant 2015 US$) of Switzerland in 2013?
Give a very brief answer. 7.88e+1. What is the difference between the Taxes (in constant 2015 US$) in Micronesia in 2010 and the Taxes (in constant 2015 US$) in Niger in 2011?
Give a very brief answer. -5.18e+08. What is the difference between the Taxes (in constant 2015 US$) of Micronesia in 2010 and the Taxes (in constant 2015 US$) of Spain in 2011?
Offer a very short reply. -1.20e+11. What is the difference between the Taxes (in constant 2015 US$) of Micronesia in 2010 and the Taxes (in constant 2015 US$) of Switzerland in 2011?
Keep it short and to the point. -2.50e+1. What is the difference between the Taxes (in constant 2015 US$) of Niger in 2010 and the Taxes (in constant 2015 US$) of Spain in 2011?
Ensure brevity in your answer.  -1.20e+11. What is the difference between the Taxes (in constant 2015 US$) of Niger in 2010 and the Taxes (in constant 2015 US$) of Switzerland in 2011?
Keep it short and to the point. -2.45e+1. What is the difference between the Taxes (in constant 2015 US$) of Spain in 2010 and the Taxes (in constant 2015 US$) of Switzerland in 2011?
Ensure brevity in your answer.  9.56e+1. What is the difference between the Taxes (in constant 2015 US$) in Micronesia in 2010 and the Taxes (in constant 2015 US$) in Niger in 2012?
Keep it short and to the point. -3.84e+08. What is the difference between the Taxes (in constant 2015 US$) of Micronesia in 2010 and the Taxes (in constant 2015 US$) of Spain in 2012?
Provide a short and direct response. -1.10e+11. What is the difference between the Taxes (in constant 2015 US$) in Micronesia in 2010 and the Taxes (in constant 2015 US$) in Switzerland in 2012?
Offer a very short reply. -2.23e+1. What is the difference between the Taxes (in constant 2015 US$) of Niger in 2010 and the Taxes (in constant 2015 US$) of Spain in 2012?
Your answer should be compact. -1.10e+11. What is the difference between the Taxes (in constant 2015 US$) of Niger in 2010 and the Taxes (in constant 2015 US$) of Switzerland in 2012?
Your answer should be compact. -2.19e+1. What is the difference between the Taxes (in constant 2015 US$) of Spain in 2010 and the Taxes (in constant 2015 US$) of Switzerland in 2012?
Provide a succinct answer. 9.82e+1. What is the difference between the Taxes (in constant 2015 US$) of Micronesia in 2010 and the Taxes (in constant 2015 US$) of Niger in 2013?
Ensure brevity in your answer.  -4.98e+08. What is the difference between the Taxes (in constant 2015 US$) in Micronesia in 2010 and the Taxes (in constant 2015 US$) in Spain in 2013?
Provide a succinct answer. -1.19e+11. What is the difference between the Taxes (in constant 2015 US$) of Micronesia in 2010 and the Taxes (in constant 2015 US$) of Switzerland in 2013?
Provide a short and direct response. -2.25e+1. What is the difference between the Taxes (in constant 2015 US$) of Niger in 2010 and the Taxes (in constant 2015 US$) of Spain in 2013?
Make the answer very short. -1.19e+11. What is the difference between the Taxes (in constant 2015 US$) of Niger in 2010 and the Taxes (in constant 2015 US$) of Switzerland in 2013?
Offer a very short reply. -2.21e+1. What is the difference between the Taxes (in constant 2015 US$) of Spain in 2010 and the Taxes (in constant 2015 US$) of Switzerland in 2013?
Offer a very short reply. 9.80e+1. What is the difference between the Taxes (in constant 2015 US$) of Micronesia in 2011 and the Taxes (in constant 2015 US$) of Niger in 2012?
Offer a very short reply. -3.83e+08. What is the difference between the Taxes (in constant 2015 US$) of Micronesia in 2011 and the Taxes (in constant 2015 US$) of Spain in 2012?
Your answer should be very brief. -1.10e+11. What is the difference between the Taxes (in constant 2015 US$) in Micronesia in 2011 and the Taxes (in constant 2015 US$) in Switzerland in 2012?
Ensure brevity in your answer.  -2.23e+1. What is the difference between the Taxes (in constant 2015 US$) of Niger in 2011 and the Taxes (in constant 2015 US$) of Spain in 2012?
Ensure brevity in your answer.  -1.10e+11. What is the difference between the Taxes (in constant 2015 US$) in Niger in 2011 and the Taxes (in constant 2015 US$) in Switzerland in 2012?
Ensure brevity in your answer.  -2.18e+1. What is the difference between the Taxes (in constant 2015 US$) in Spain in 2011 and the Taxes (in constant 2015 US$) in Switzerland in 2012?
Your answer should be compact. 9.81e+1. What is the difference between the Taxes (in constant 2015 US$) of Micronesia in 2011 and the Taxes (in constant 2015 US$) of Niger in 2013?
Make the answer very short. -4.97e+08. What is the difference between the Taxes (in constant 2015 US$) of Micronesia in 2011 and the Taxes (in constant 2015 US$) of Spain in 2013?
Your response must be concise. -1.19e+11. What is the difference between the Taxes (in constant 2015 US$) in Micronesia in 2011 and the Taxes (in constant 2015 US$) in Switzerland in 2013?
Keep it short and to the point. -2.25e+1. What is the difference between the Taxes (in constant 2015 US$) of Niger in 2011 and the Taxes (in constant 2015 US$) of Spain in 2013?
Offer a terse response. -1.19e+11. What is the difference between the Taxes (in constant 2015 US$) in Niger in 2011 and the Taxes (in constant 2015 US$) in Switzerland in 2013?
Offer a very short reply. -2.20e+1. What is the difference between the Taxes (in constant 2015 US$) of Spain in 2011 and the Taxes (in constant 2015 US$) of Switzerland in 2013?
Offer a terse response. 9.80e+1. What is the difference between the Taxes (in constant 2015 US$) in Micronesia in 2012 and the Taxes (in constant 2015 US$) in Niger in 2013?
Keep it short and to the point. -4.97e+08. What is the difference between the Taxes (in constant 2015 US$) of Micronesia in 2012 and the Taxes (in constant 2015 US$) of Spain in 2013?
Provide a short and direct response. -1.19e+11. What is the difference between the Taxes (in constant 2015 US$) in Micronesia in 2012 and the Taxes (in constant 2015 US$) in Switzerland in 2013?
Keep it short and to the point. -2.25e+1. What is the difference between the Taxes (in constant 2015 US$) of Niger in 2012 and the Taxes (in constant 2015 US$) of Spain in 2013?
Keep it short and to the point. -1.19e+11. What is the difference between the Taxes (in constant 2015 US$) in Niger in 2012 and the Taxes (in constant 2015 US$) in Switzerland in 2013?
Give a very brief answer. -2.21e+1. What is the difference between the Taxes (in constant 2015 US$) of Spain in 2012 and the Taxes (in constant 2015 US$) of Switzerland in 2013?
Ensure brevity in your answer.  8.76e+1. What is the average Taxes (in constant 2015 US$) of Micronesia per year?
Ensure brevity in your answer.  2.32e+07. What is the average Taxes (in constant 2015 US$) of Niger per year?
Your answer should be very brief. 4.04e+08. What is the average Taxes (in constant 2015 US$) in Spain per year?
Make the answer very short. 1.23e+11. What is the average Taxes (in constant 2015 US$) in Switzerland per year?
Offer a terse response. 2.09e+1. In the year 2006, what is the difference between the Taxes (in constant 2015 US$) of Micronesia and Taxes (in constant 2015 US$) of Niger?
Give a very brief answer. -2.43e+08. In the year 2006, what is the difference between the Taxes (in constant 2015 US$) in Micronesia and Taxes (in constant 2015 US$) in Spain?
Give a very brief answer. -1.35e+11. In the year 2006, what is the difference between the Taxes (in constant 2015 US$) of Micronesia and Taxes (in constant 2015 US$) of Switzerland?
Your answer should be compact. -1.69e+1. In the year 2006, what is the difference between the Taxes (in constant 2015 US$) of Niger and Taxes (in constant 2015 US$) of Spain?
Give a very brief answer. -1.35e+11. In the year 2006, what is the difference between the Taxes (in constant 2015 US$) in Niger and Taxes (in constant 2015 US$) in Switzerland?
Keep it short and to the point. -1.67e+1. In the year 2006, what is the difference between the Taxes (in constant 2015 US$) of Spain and Taxes (in constant 2015 US$) of Switzerland?
Provide a short and direct response. 1.18e+11. In the year 2007, what is the difference between the Taxes (in constant 2015 US$) in Micronesia and Taxes (in constant 2015 US$) in Niger?
Your answer should be very brief. -2.82e+08. In the year 2007, what is the difference between the Taxes (in constant 2015 US$) in Micronesia and Taxes (in constant 2015 US$) in Spain?
Your answer should be very brief. -1.48e+11. In the year 2007, what is the difference between the Taxes (in constant 2015 US$) in Micronesia and Taxes (in constant 2015 US$) in Switzerland?
Make the answer very short. -1.86e+1. In the year 2007, what is the difference between the Taxes (in constant 2015 US$) of Niger and Taxes (in constant 2015 US$) of Spain?
Ensure brevity in your answer.  -1.47e+11. In the year 2007, what is the difference between the Taxes (in constant 2015 US$) in Niger and Taxes (in constant 2015 US$) in Switzerland?
Give a very brief answer. -1.83e+1. In the year 2007, what is the difference between the Taxes (in constant 2015 US$) in Spain and Taxes (in constant 2015 US$) in Switzerland?
Offer a very short reply. 1.29e+11. In the year 2008, what is the difference between the Taxes (in constant 2015 US$) in Micronesia and Taxes (in constant 2015 US$) in Niger?
Offer a very short reply. -3.53e+08. In the year 2008, what is the difference between the Taxes (in constant 2015 US$) in Micronesia and Taxes (in constant 2015 US$) in Spain?
Give a very brief answer. -1.33e+11. In the year 2008, what is the difference between the Taxes (in constant 2015 US$) of Micronesia and Taxes (in constant 2015 US$) of Switzerland?
Offer a very short reply. -2.08e+1. In the year 2008, what is the difference between the Taxes (in constant 2015 US$) of Niger and Taxes (in constant 2015 US$) of Spain?
Ensure brevity in your answer.  -1.32e+11. In the year 2008, what is the difference between the Taxes (in constant 2015 US$) in Niger and Taxes (in constant 2015 US$) in Switzerland?
Offer a terse response. -2.05e+1. In the year 2008, what is the difference between the Taxes (in constant 2015 US$) in Spain and Taxes (in constant 2015 US$) in Switzerland?
Keep it short and to the point. 1.12e+11. In the year 2009, what is the difference between the Taxes (in constant 2015 US$) in Micronesia and Taxes (in constant 2015 US$) in Niger?
Your response must be concise. -3.71e+08. In the year 2009, what is the difference between the Taxes (in constant 2015 US$) in Micronesia and Taxes (in constant 2015 US$) in Spain?
Ensure brevity in your answer.  -1.01e+11. In the year 2009, what is the difference between the Taxes (in constant 2015 US$) in Micronesia and Taxes (in constant 2015 US$) in Switzerland?
Offer a terse response. -1.93e+1. In the year 2009, what is the difference between the Taxes (in constant 2015 US$) of Niger and Taxes (in constant 2015 US$) of Spain?
Your response must be concise. -1.01e+11. In the year 2009, what is the difference between the Taxes (in constant 2015 US$) of Niger and Taxes (in constant 2015 US$) of Switzerland?
Give a very brief answer. -1.90e+1. In the year 2009, what is the difference between the Taxes (in constant 2015 US$) in Spain and Taxes (in constant 2015 US$) in Switzerland?
Make the answer very short. 8.19e+1. In the year 2010, what is the difference between the Taxes (in constant 2015 US$) of Micronesia and Taxes (in constant 2015 US$) of Niger?
Offer a terse response. -4.03e+08. In the year 2010, what is the difference between the Taxes (in constant 2015 US$) in Micronesia and Taxes (in constant 2015 US$) in Spain?
Give a very brief answer. -1.21e+11. In the year 2010, what is the difference between the Taxes (in constant 2015 US$) in Micronesia and Taxes (in constant 2015 US$) in Switzerland?
Offer a very short reply. -2.14e+1. In the year 2010, what is the difference between the Taxes (in constant 2015 US$) of Niger and Taxes (in constant 2015 US$) of Spain?
Offer a terse response. -1.20e+11. In the year 2010, what is the difference between the Taxes (in constant 2015 US$) of Niger and Taxes (in constant 2015 US$) of Switzerland?
Make the answer very short. -2.10e+1. In the year 2010, what is the difference between the Taxes (in constant 2015 US$) in Spain and Taxes (in constant 2015 US$) in Switzerland?
Give a very brief answer. 9.91e+1. In the year 2011, what is the difference between the Taxes (in constant 2015 US$) of Micronesia and Taxes (in constant 2015 US$) of Niger?
Your answer should be very brief. -5.18e+08. In the year 2011, what is the difference between the Taxes (in constant 2015 US$) of Micronesia and Taxes (in constant 2015 US$) of Spain?
Provide a succinct answer. -1.20e+11. In the year 2011, what is the difference between the Taxes (in constant 2015 US$) of Micronesia and Taxes (in constant 2015 US$) of Switzerland?
Your answer should be compact. -2.50e+1. In the year 2011, what is the difference between the Taxes (in constant 2015 US$) of Niger and Taxes (in constant 2015 US$) of Spain?
Offer a terse response. -1.20e+11. In the year 2011, what is the difference between the Taxes (in constant 2015 US$) of Niger and Taxes (in constant 2015 US$) of Switzerland?
Your answer should be compact. -2.44e+1. In the year 2011, what is the difference between the Taxes (in constant 2015 US$) in Spain and Taxes (in constant 2015 US$) in Switzerland?
Give a very brief answer. 9.55e+1. In the year 2012, what is the difference between the Taxes (in constant 2015 US$) in Micronesia and Taxes (in constant 2015 US$) in Niger?
Your answer should be compact. -3.83e+08. In the year 2012, what is the difference between the Taxes (in constant 2015 US$) in Micronesia and Taxes (in constant 2015 US$) in Spain?
Ensure brevity in your answer.  -1.10e+11. In the year 2012, what is the difference between the Taxes (in constant 2015 US$) in Micronesia and Taxes (in constant 2015 US$) in Switzerland?
Ensure brevity in your answer.  -2.23e+1. In the year 2012, what is the difference between the Taxes (in constant 2015 US$) in Niger and Taxes (in constant 2015 US$) in Spain?
Provide a succinct answer. -1.10e+11. In the year 2012, what is the difference between the Taxes (in constant 2015 US$) in Niger and Taxes (in constant 2015 US$) in Switzerland?
Offer a very short reply. -2.20e+1. In the year 2012, what is the difference between the Taxes (in constant 2015 US$) of Spain and Taxes (in constant 2015 US$) of Switzerland?
Offer a very short reply. 8.78e+1. In the year 2013, what is the difference between the Taxes (in constant 2015 US$) in Micronesia and Taxes (in constant 2015 US$) in Niger?
Offer a terse response. -4.97e+08. In the year 2013, what is the difference between the Taxes (in constant 2015 US$) in Micronesia and Taxes (in constant 2015 US$) in Spain?
Keep it short and to the point. -1.19e+11. In the year 2013, what is the difference between the Taxes (in constant 2015 US$) in Micronesia and Taxes (in constant 2015 US$) in Switzerland?
Make the answer very short. -2.25e+1. In the year 2013, what is the difference between the Taxes (in constant 2015 US$) in Niger and Taxes (in constant 2015 US$) in Spain?
Your response must be concise. -1.19e+11. In the year 2013, what is the difference between the Taxes (in constant 2015 US$) in Niger and Taxes (in constant 2015 US$) in Switzerland?
Ensure brevity in your answer.  -2.20e+1. In the year 2013, what is the difference between the Taxes (in constant 2015 US$) in Spain and Taxes (in constant 2015 US$) in Switzerland?
Offer a terse response. 9.69e+1. What is the ratio of the Taxes (in constant 2015 US$) of Micronesia in 2006 to that in 2007?
Your answer should be compact. 1.03. What is the ratio of the Taxes (in constant 2015 US$) in Niger in 2006 to that in 2007?
Keep it short and to the point. 0.88. What is the ratio of the Taxes (in constant 2015 US$) of Spain in 2006 to that in 2007?
Make the answer very short. 0.92. What is the ratio of the Taxes (in constant 2015 US$) in Switzerland in 2006 to that in 2007?
Ensure brevity in your answer.  0.91. What is the ratio of the Taxes (in constant 2015 US$) of Micronesia in 2006 to that in 2008?
Your answer should be compact. 1.12. What is the ratio of the Taxes (in constant 2015 US$) in Niger in 2006 to that in 2008?
Your answer should be very brief. 0.71. What is the ratio of the Taxes (in constant 2015 US$) in Spain in 2006 to that in 2008?
Make the answer very short. 1.02. What is the ratio of the Taxes (in constant 2015 US$) of Switzerland in 2006 to that in 2008?
Give a very brief answer. 0.81. What is the ratio of the Taxes (in constant 2015 US$) of Micronesia in 2006 to that in 2009?
Offer a terse response. 0.96. What is the ratio of the Taxes (in constant 2015 US$) in Niger in 2006 to that in 2009?
Your answer should be very brief. 0.67. What is the ratio of the Taxes (in constant 2015 US$) of Spain in 2006 to that in 2009?
Keep it short and to the point. 1.34. What is the ratio of the Taxes (in constant 2015 US$) of Switzerland in 2006 to that in 2009?
Offer a very short reply. 0.87. What is the ratio of the Taxes (in constant 2015 US$) of Micronesia in 2006 to that in 2010?
Keep it short and to the point. 0.83. What is the ratio of the Taxes (in constant 2015 US$) in Niger in 2006 to that in 2010?
Keep it short and to the point. 0.62. What is the ratio of the Taxes (in constant 2015 US$) in Spain in 2006 to that in 2010?
Make the answer very short. 1.12. What is the ratio of the Taxes (in constant 2015 US$) in Switzerland in 2006 to that in 2010?
Provide a short and direct response. 0.79. What is the ratio of the Taxes (in constant 2015 US$) of Micronesia in 2006 to that in 2011?
Make the answer very short. 0.81. What is the ratio of the Taxes (in constant 2015 US$) in Niger in 2006 to that in 2011?
Give a very brief answer. 0.49. What is the ratio of the Taxes (in constant 2015 US$) of Spain in 2006 to that in 2011?
Give a very brief answer. 1.12. What is the ratio of the Taxes (in constant 2015 US$) of Switzerland in 2006 to that in 2011?
Your answer should be very brief. 0.68. What is the ratio of the Taxes (in constant 2015 US$) in Micronesia in 2006 to that in 2012?
Your response must be concise. 0.8. What is the ratio of the Taxes (in constant 2015 US$) in Niger in 2006 to that in 2012?
Provide a succinct answer. 0.65. What is the ratio of the Taxes (in constant 2015 US$) of Spain in 2006 to that in 2012?
Give a very brief answer. 1.23. What is the ratio of the Taxes (in constant 2015 US$) of Switzerland in 2006 to that in 2012?
Give a very brief answer. 0.76. What is the ratio of the Taxes (in constant 2015 US$) of Micronesia in 2006 to that in 2013?
Your answer should be compact. 0.81. What is the ratio of the Taxes (in constant 2015 US$) in Niger in 2006 to that in 2013?
Ensure brevity in your answer.  0.51. What is the ratio of the Taxes (in constant 2015 US$) in Spain in 2006 to that in 2013?
Keep it short and to the point. 1.13. What is the ratio of the Taxes (in constant 2015 US$) in Switzerland in 2006 to that in 2013?
Make the answer very short. 0.75. What is the ratio of the Taxes (in constant 2015 US$) in Micronesia in 2007 to that in 2008?
Provide a succinct answer. 1.08. What is the ratio of the Taxes (in constant 2015 US$) in Niger in 2007 to that in 2008?
Offer a terse response. 0.81. What is the ratio of the Taxes (in constant 2015 US$) of Spain in 2007 to that in 2008?
Ensure brevity in your answer.  1.11. What is the ratio of the Taxes (in constant 2015 US$) of Switzerland in 2007 to that in 2008?
Give a very brief answer. 0.89. What is the ratio of the Taxes (in constant 2015 US$) of Micronesia in 2007 to that in 2009?
Offer a terse response. 0.93. What is the ratio of the Taxes (in constant 2015 US$) of Niger in 2007 to that in 2009?
Your answer should be very brief. 0.77. What is the ratio of the Taxes (in constant 2015 US$) of Spain in 2007 to that in 2009?
Your answer should be very brief. 1.46. What is the ratio of the Taxes (in constant 2015 US$) of Switzerland in 2007 to that in 2009?
Provide a succinct answer. 0.96. What is the ratio of the Taxes (in constant 2015 US$) of Micronesia in 2007 to that in 2010?
Keep it short and to the point. 0.8. What is the ratio of the Taxes (in constant 2015 US$) in Niger in 2007 to that in 2010?
Ensure brevity in your answer.  0.71. What is the ratio of the Taxes (in constant 2015 US$) in Spain in 2007 to that in 2010?
Make the answer very short. 1.23. What is the ratio of the Taxes (in constant 2015 US$) in Switzerland in 2007 to that in 2010?
Offer a terse response. 0.87. What is the ratio of the Taxes (in constant 2015 US$) of Micronesia in 2007 to that in 2011?
Offer a very short reply. 0.78. What is the ratio of the Taxes (in constant 2015 US$) of Niger in 2007 to that in 2011?
Give a very brief answer. 0.56. What is the ratio of the Taxes (in constant 2015 US$) of Spain in 2007 to that in 2011?
Offer a very short reply. 1.23. What is the ratio of the Taxes (in constant 2015 US$) in Switzerland in 2007 to that in 2011?
Provide a succinct answer. 0.75. What is the ratio of the Taxes (in constant 2015 US$) of Micronesia in 2007 to that in 2012?
Your answer should be compact. 0.78. What is the ratio of the Taxes (in constant 2015 US$) of Niger in 2007 to that in 2012?
Give a very brief answer. 0.74. What is the ratio of the Taxes (in constant 2015 US$) of Spain in 2007 to that in 2012?
Offer a terse response. 1.34. What is the ratio of the Taxes (in constant 2015 US$) in Switzerland in 2007 to that in 2012?
Your answer should be very brief. 0.83. What is the ratio of the Taxes (in constant 2015 US$) in Micronesia in 2007 to that in 2013?
Offer a very short reply. 0.79. What is the ratio of the Taxes (in constant 2015 US$) of Niger in 2007 to that in 2013?
Provide a short and direct response. 0.58. What is the ratio of the Taxes (in constant 2015 US$) of Spain in 2007 to that in 2013?
Offer a very short reply. 1.24. What is the ratio of the Taxes (in constant 2015 US$) in Switzerland in 2007 to that in 2013?
Provide a short and direct response. 0.83. What is the ratio of the Taxes (in constant 2015 US$) of Micronesia in 2008 to that in 2009?
Offer a very short reply. 0.85. What is the ratio of the Taxes (in constant 2015 US$) of Niger in 2008 to that in 2009?
Offer a terse response. 0.95. What is the ratio of the Taxes (in constant 2015 US$) in Spain in 2008 to that in 2009?
Your answer should be compact. 1.31. What is the ratio of the Taxes (in constant 2015 US$) of Switzerland in 2008 to that in 2009?
Your answer should be compact. 1.08. What is the ratio of the Taxes (in constant 2015 US$) in Micronesia in 2008 to that in 2010?
Your response must be concise. 0.74. What is the ratio of the Taxes (in constant 2015 US$) of Niger in 2008 to that in 2010?
Provide a succinct answer. 0.87. What is the ratio of the Taxes (in constant 2015 US$) in Spain in 2008 to that in 2010?
Make the answer very short. 1.1. What is the ratio of the Taxes (in constant 2015 US$) of Micronesia in 2008 to that in 2011?
Your response must be concise. 0.72. What is the ratio of the Taxes (in constant 2015 US$) of Niger in 2008 to that in 2011?
Provide a short and direct response. 0.68. What is the ratio of the Taxes (in constant 2015 US$) in Spain in 2008 to that in 2011?
Your answer should be compact. 1.1. What is the ratio of the Taxes (in constant 2015 US$) of Switzerland in 2008 to that in 2011?
Give a very brief answer. 0.83. What is the ratio of the Taxes (in constant 2015 US$) of Micronesia in 2008 to that in 2012?
Offer a terse response. 0.72. What is the ratio of the Taxes (in constant 2015 US$) of Niger in 2008 to that in 2012?
Offer a very short reply. 0.91. What is the ratio of the Taxes (in constant 2015 US$) in Spain in 2008 to that in 2012?
Ensure brevity in your answer.  1.2. What is the ratio of the Taxes (in constant 2015 US$) in Switzerland in 2008 to that in 2012?
Your answer should be very brief. 0.93. What is the ratio of the Taxes (in constant 2015 US$) in Micronesia in 2008 to that in 2013?
Offer a very short reply. 0.73. What is the ratio of the Taxes (in constant 2015 US$) of Niger in 2008 to that in 2013?
Provide a succinct answer. 0.71. What is the ratio of the Taxes (in constant 2015 US$) in Spain in 2008 to that in 2013?
Provide a short and direct response. 1.11. What is the ratio of the Taxes (in constant 2015 US$) in Switzerland in 2008 to that in 2013?
Keep it short and to the point. 0.92. What is the ratio of the Taxes (in constant 2015 US$) in Micronesia in 2009 to that in 2010?
Make the answer very short. 0.87. What is the ratio of the Taxes (in constant 2015 US$) of Niger in 2009 to that in 2010?
Your answer should be very brief. 0.92. What is the ratio of the Taxes (in constant 2015 US$) in Spain in 2009 to that in 2010?
Your answer should be very brief. 0.84. What is the ratio of the Taxes (in constant 2015 US$) of Switzerland in 2009 to that in 2010?
Your answer should be compact. 0.9. What is the ratio of the Taxes (in constant 2015 US$) in Micronesia in 2009 to that in 2011?
Offer a terse response. 0.85. What is the ratio of the Taxes (in constant 2015 US$) in Niger in 2009 to that in 2011?
Provide a short and direct response. 0.72. What is the ratio of the Taxes (in constant 2015 US$) of Spain in 2009 to that in 2011?
Give a very brief answer. 0.84. What is the ratio of the Taxes (in constant 2015 US$) in Switzerland in 2009 to that in 2011?
Your response must be concise. 0.78. What is the ratio of the Taxes (in constant 2015 US$) of Micronesia in 2009 to that in 2012?
Keep it short and to the point. 0.84. What is the ratio of the Taxes (in constant 2015 US$) in Niger in 2009 to that in 2012?
Offer a very short reply. 0.96. What is the ratio of the Taxes (in constant 2015 US$) in Spain in 2009 to that in 2012?
Offer a terse response. 0.92. What is the ratio of the Taxes (in constant 2015 US$) in Switzerland in 2009 to that in 2012?
Keep it short and to the point. 0.87. What is the ratio of the Taxes (in constant 2015 US$) of Micronesia in 2009 to that in 2013?
Provide a short and direct response. 0.85. What is the ratio of the Taxes (in constant 2015 US$) in Niger in 2009 to that in 2013?
Offer a very short reply. 0.75. What is the ratio of the Taxes (in constant 2015 US$) in Spain in 2009 to that in 2013?
Your answer should be very brief. 0.85. What is the ratio of the Taxes (in constant 2015 US$) in Switzerland in 2009 to that in 2013?
Offer a very short reply. 0.86. What is the ratio of the Taxes (in constant 2015 US$) of Micronesia in 2010 to that in 2011?
Provide a succinct answer. 0.98. What is the ratio of the Taxes (in constant 2015 US$) of Niger in 2010 to that in 2011?
Offer a terse response. 0.79. What is the ratio of the Taxes (in constant 2015 US$) in Spain in 2010 to that in 2011?
Your response must be concise. 1. What is the ratio of the Taxes (in constant 2015 US$) in Switzerland in 2010 to that in 2011?
Your answer should be compact. 0.86. What is the ratio of the Taxes (in constant 2015 US$) in Micronesia in 2010 to that in 2012?
Keep it short and to the point. 0.97. What is the ratio of the Taxes (in constant 2015 US$) in Niger in 2010 to that in 2012?
Make the answer very short. 1.05. What is the ratio of the Taxes (in constant 2015 US$) of Spain in 2010 to that in 2012?
Provide a succinct answer. 1.09. What is the ratio of the Taxes (in constant 2015 US$) in Switzerland in 2010 to that in 2012?
Your answer should be very brief. 0.96. What is the ratio of the Taxes (in constant 2015 US$) in Micronesia in 2010 to that in 2013?
Provide a short and direct response. 0.98. What is the ratio of the Taxes (in constant 2015 US$) of Niger in 2010 to that in 2013?
Offer a very short reply. 0.82. What is the ratio of the Taxes (in constant 2015 US$) of Spain in 2010 to that in 2013?
Offer a terse response. 1.01. What is the ratio of the Taxes (in constant 2015 US$) of Switzerland in 2010 to that in 2013?
Provide a succinct answer. 0.95. What is the ratio of the Taxes (in constant 2015 US$) of Micronesia in 2011 to that in 2012?
Your response must be concise. 0.99. What is the ratio of the Taxes (in constant 2015 US$) in Niger in 2011 to that in 2012?
Make the answer very short. 1.33. What is the ratio of the Taxes (in constant 2015 US$) in Spain in 2011 to that in 2012?
Your answer should be very brief. 1.09. What is the ratio of the Taxes (in constant 2015 US$) in Switzerland in 2011 to that in 2012?
Keep it short and to the point. 1.12. What is the ratio of the Taxes (in constant 2015 US$) of Niger in 2011 to that in 2013?
Give a very brief answer. 1.04. What is the ratio of the Taxes (in constant 2015 US$) in Spain in 2011 to that in 2013?
Your answer should be compact. 1.01. What is the ratio of the Taxes (in constant 2015 US$) of Switzerland in 2011 to that in 2013?
Ensure brevity in your answer.  1.11. What is the ratio of the Taxes (in constant 2015 US$) of Micronesia in 2012 to that in 2013?
Give a very brief answer. 1.02. What is the ratio of the Taxes (in constant 2015 US$) of Niger in 2012 to that in 2013?
Give a very brief answer. 0.78. What is the ratio of the Taxes (in constant 2015 US$) in Spain in 2012 to that in 2013?
Make the answer very short. 0.92. What is the difference between the highest and the second highest Taxes (in constant 2015 US$) of Micronesia?
Give a very brief answer. 2.83e+05. What is the difference between the highest and the second highest Taxes (in constant 2015 US$) of Niger?
Your answer should be very brief. 2.08e+07. What is the difference between the highest and the second highest Taxes (in constant 2015 US$) of Spain?
Provide a short and direct response. 1.24e+1. What is the difference between the highest and the second highest Taxes (in constant 2015 US$) in Switzerland?
Provide a short and direct response. 2.45e+09. What is the difference between the highest and the lowest Taxes (in constant 2015 US$) in Micronesia?
Provide a short and direct response. 7.48e+06. What is the difference between the highest and the lowest Taxes (in constant 2015 US$) in Niger?
Offer a terse response. 2.79e+08. What is the difference between the highest and the lowest Taxes (in constant 2015 US$) of Spain?
Your response must be concise. 4.65e+1. What is the difference between the highest and the lowest Taxes (in constant 2015 US$) in Switzerland?
Provide a succinct answer. 8.05e+09. 